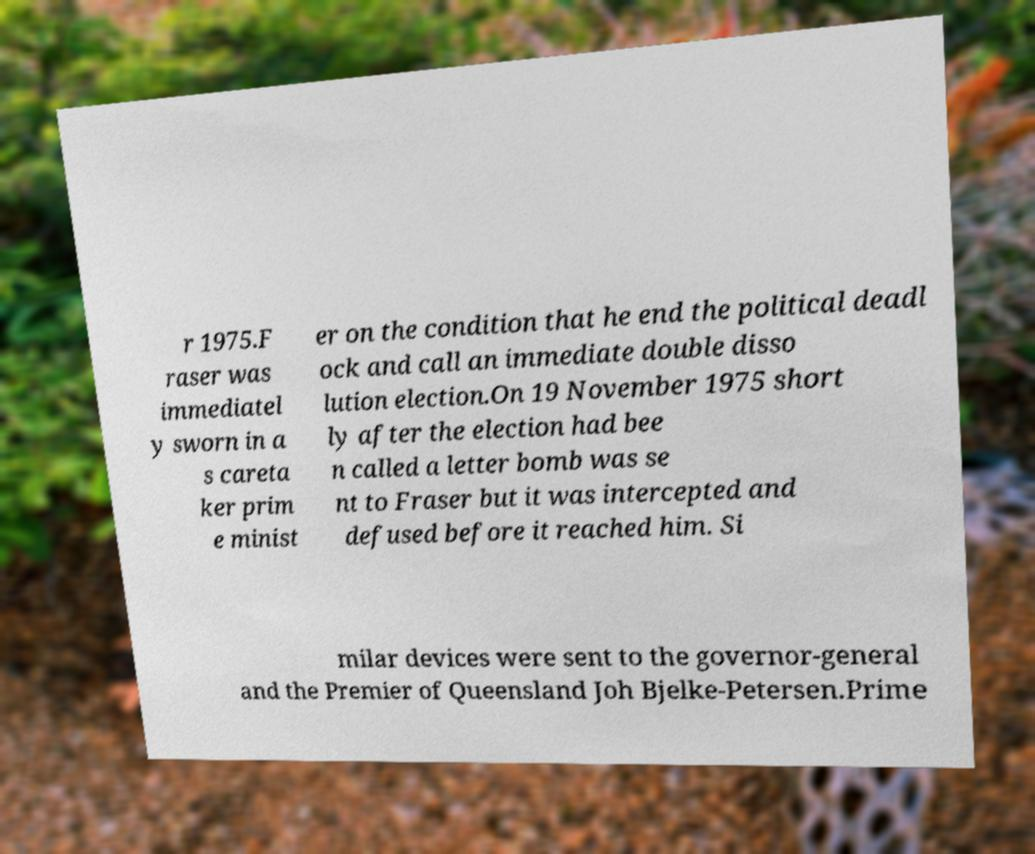Could you extract and type out the text from this image? r 1975.F raser was immediatel y sworn in a s careta ker prim e minist er on the condition that he end the political deadl ock and call an immediate double disso lution election.On 19 November 1975 short ly after the election had bee n called a letter bomb was se nt to Fraser but it was intercepted and defused before it reached him. Si milar devices were sent to the governor-general and the Premier of Queensland Joh Bjelke-Petersen.Prime 